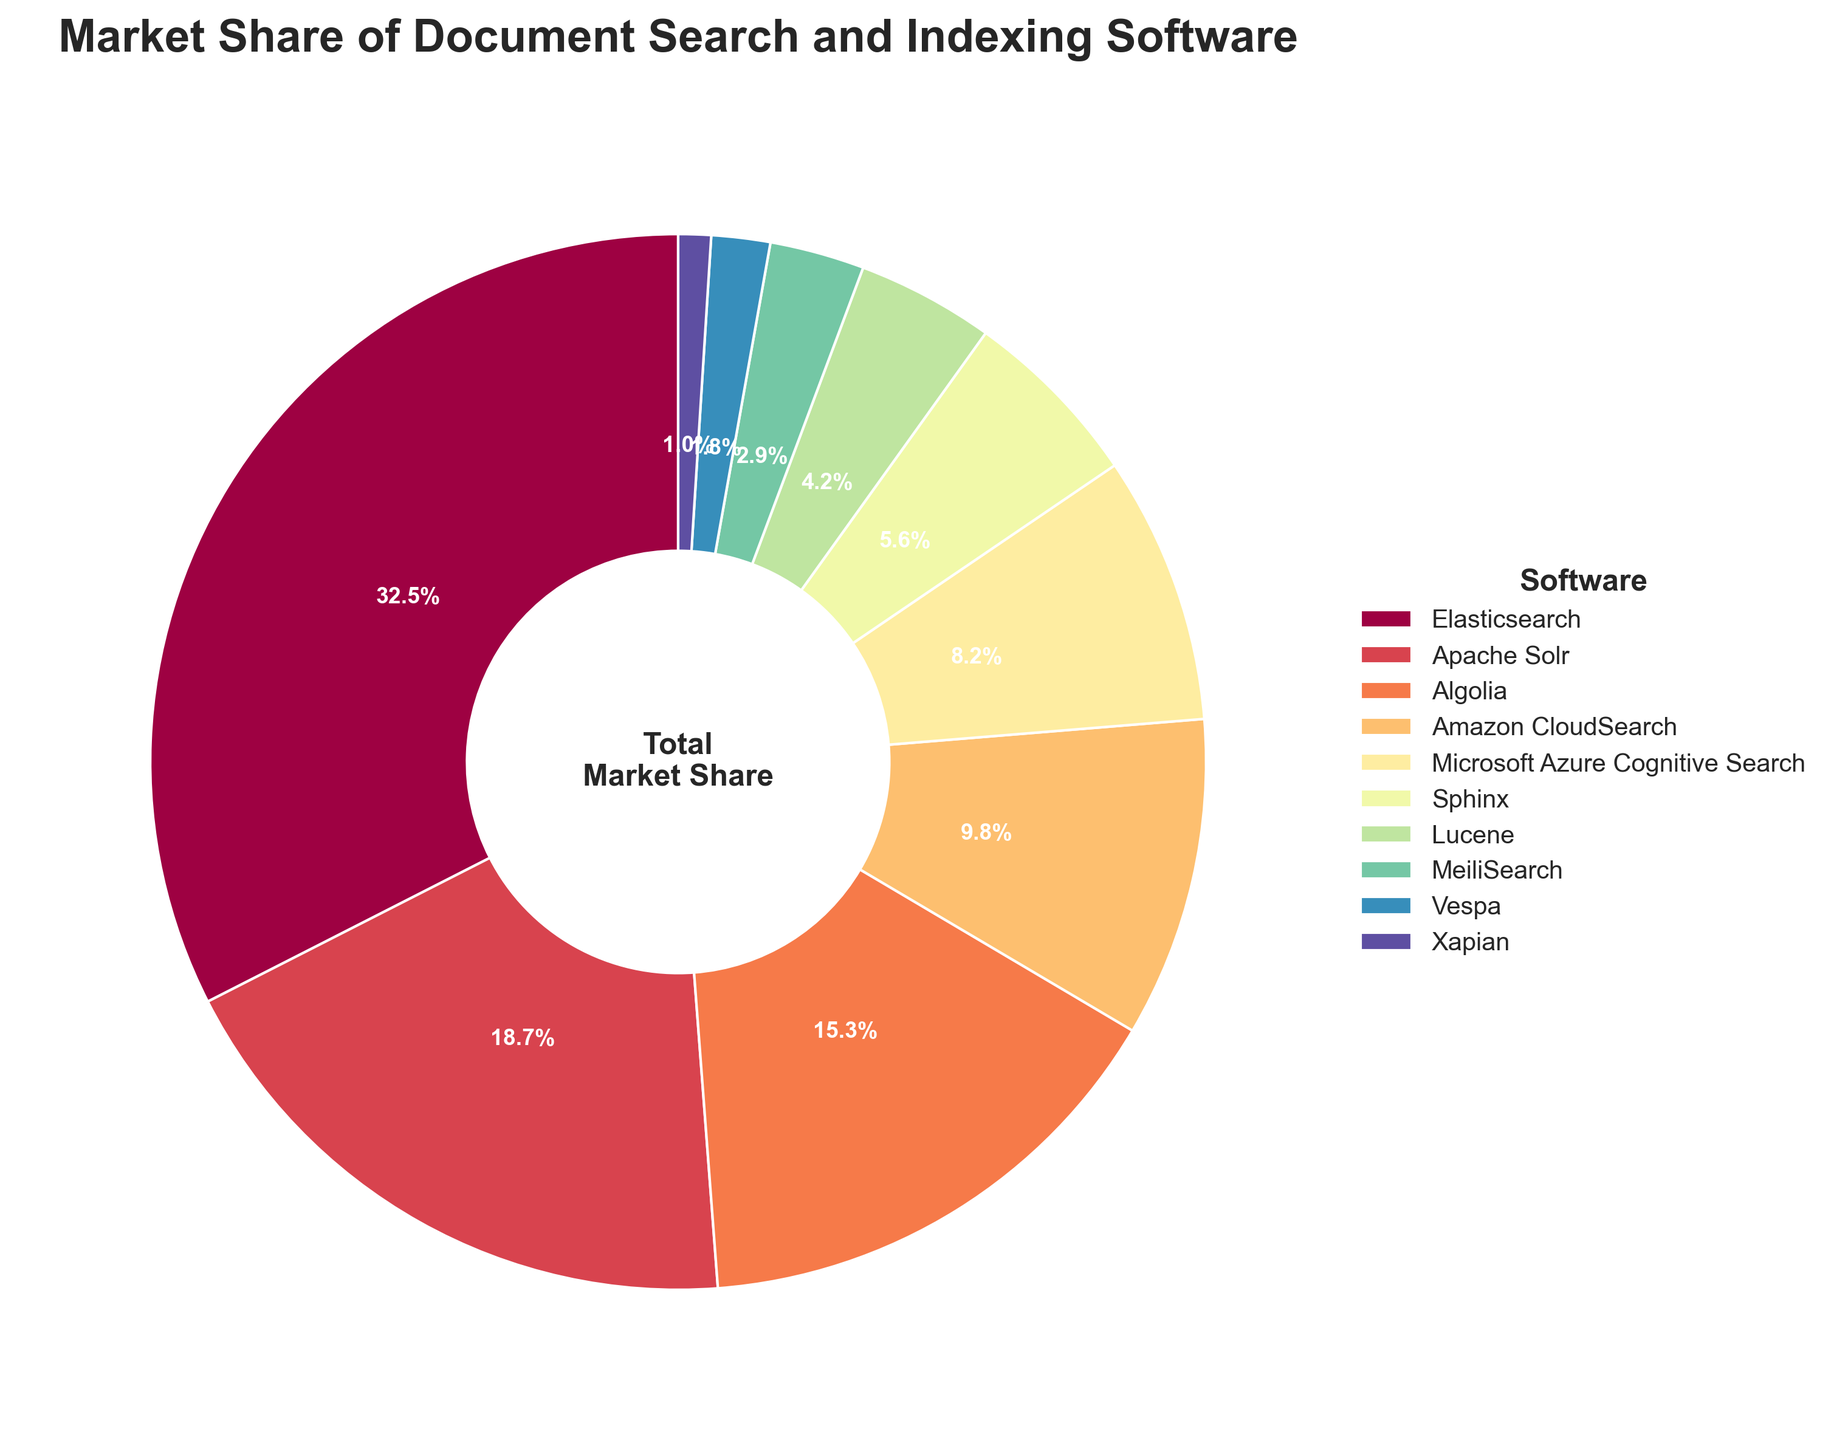What is the market share of Elasticsearch? Look for the slice labeled "Elasticsearch" on the pie chart and refer to its corresponding percentage.
Answer: 32.5% Which software has the lowest market share? Identify the smallest slice on the pie chart, see which software it represents, and note its percentage.
Answer: Xapian How much larger is Elasticsearch's market share compared to Algolia's? Find the market shares of Elasticsearch (32.5%) and Algolia (15.3%). Subtract Algolia's share from Elasticsearch's: 32.5% - 15.3% = 17.2%.
Answer: 17.2% What is the combined market share of Apache Solr and Amazon CloudSearch? Locate the market shares of Apache Solr (18.7%) and Amazon CloudSearch (9.8%). Add them together: 18.7% + 9.8% = 28.5%.
Answer: 28.5% How many software platforms have a market share above 10%? Identify the slices labeled with market shares above 10%. There are three: Elasticsearch (32.5%), Apache Solr (18.7%), and Algolia (15.3%).
Answer: 3 Which software is represented by the darkest color? The pie chart uses a colormap that typically transitions from light to dark. The software with the largest slice usually has the darkest color. Check the color progression and identify Elasticsearch as having the darkest color.
Answer: Elasticsearch Is Microsoft Azure Cognitive Search's market share greater than Sphinx's? Compare the market shares of Microsoft Azure Cognitive Search (8.2%) and Sphinx (5.6%). Since 8.2% > 5.6%, the answer is yes.
Answer: Yes What percentage of the market share is represented by software platforms with less than 5% individually? Identify the platforms with less than 5% market share (Sphinx, Lucene, MeiliSearch, Vespa, Xapian) and add their percentages: 5.6% + 4.2% + 2.9% + 1.8% + 1.0% = 15.5%.
Answer: 15.5% What is the visual representation of the total market share in the pie chart’s center? The center of the pie chart typically features a central label or note. It says "Total Market Share".
Answer: Total Market Share 